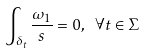<formula> <loc_0><loc_0><loc_500><loc_500>\int _ { \delta _ { t } } \frac { \omega _ { 1 } } { s } = 0 , \ \forall t \in \Sigma</formula> 